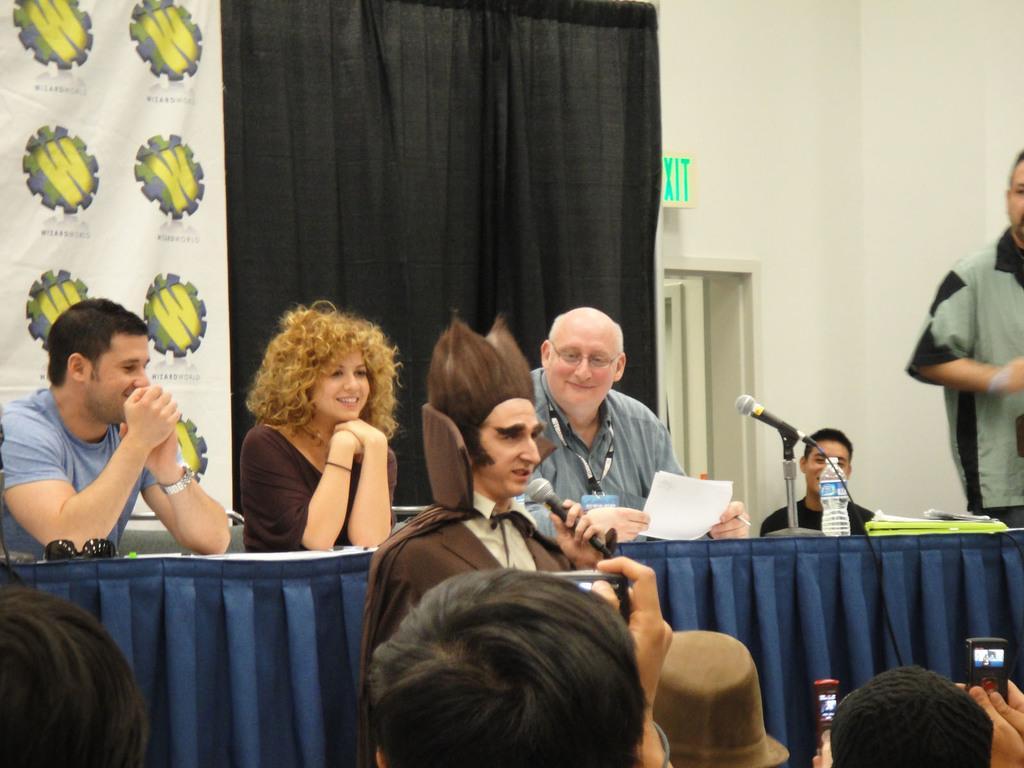In one or two sentences, can you explain what this image depicts? In this image i can see three persons sit on the chair and put their hands on the table and there is a cloth on the table and there is spectacles ,mike bottle , book on the table. there are three persons on the middle there is a woman she is wearing a brown color shirt and she is having a curly hair with brown color she is smiling in front of him there is a man with gray color shirt his mouth was open. and he's holding a mike. there are and some persons taking pictures on the mobile phones. and on the left side there is a man sit on the chair wearing a id card 